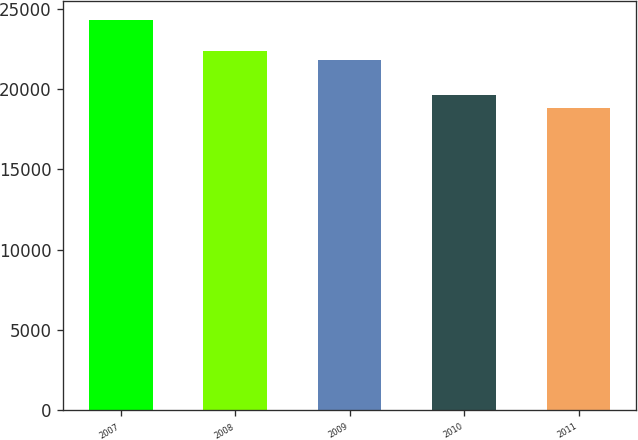Convert chart. <chart><loc_0><loc_0><loc_500><loc_500><bar_chart><fcel>2007<fcel>2008<fcel>2009<fcel>2010<fcel>2011<nl><fcel>24275<fcel>22354.7<fcel>21808<fcel>19613<fcel>18808<nl></chart> 